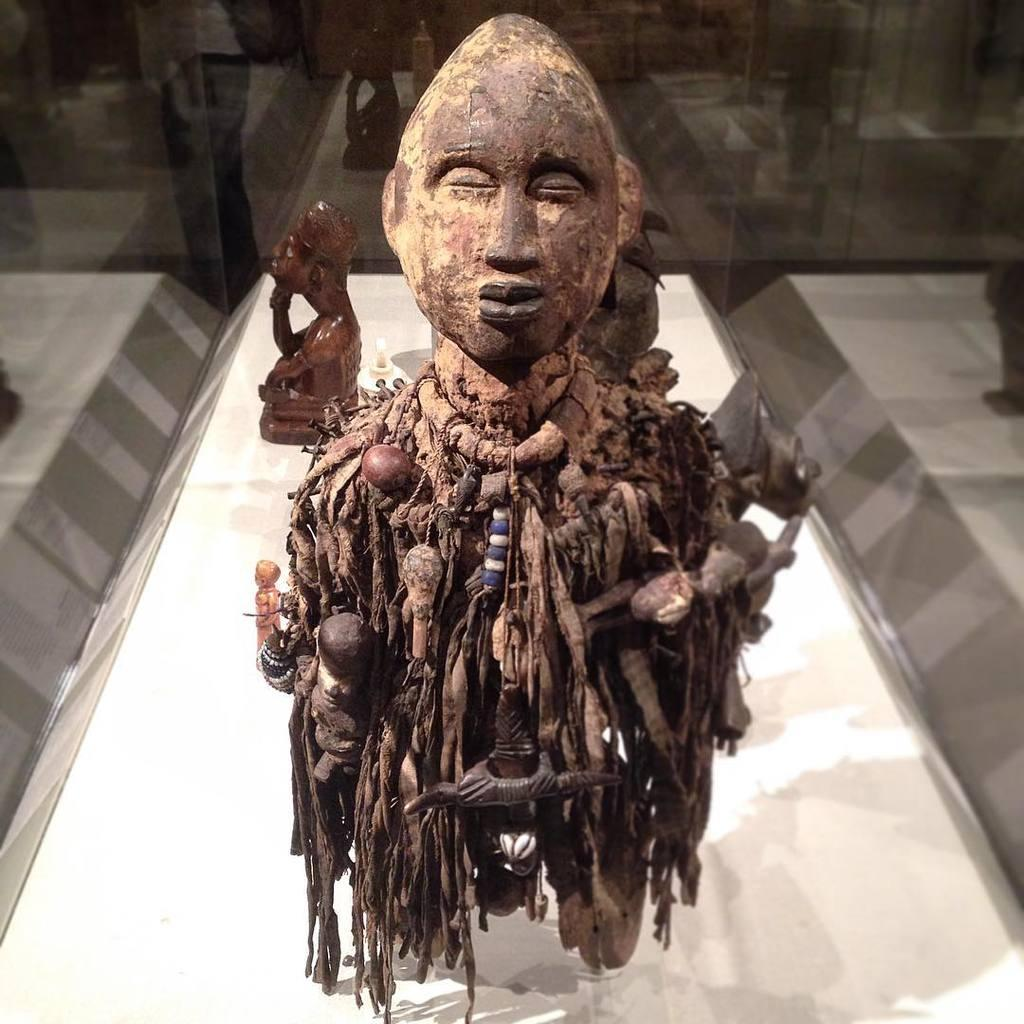What is located on the white platform in the image? There are sculptures on a white platform in the image. What can be seen on the sculptures? There are items on the sculptures. What is visible in the background of the image? There is a glass wall in the background. What country is hosting the event depicted in the image? There is no event depicted in the image, and therefore no country hosting it. 